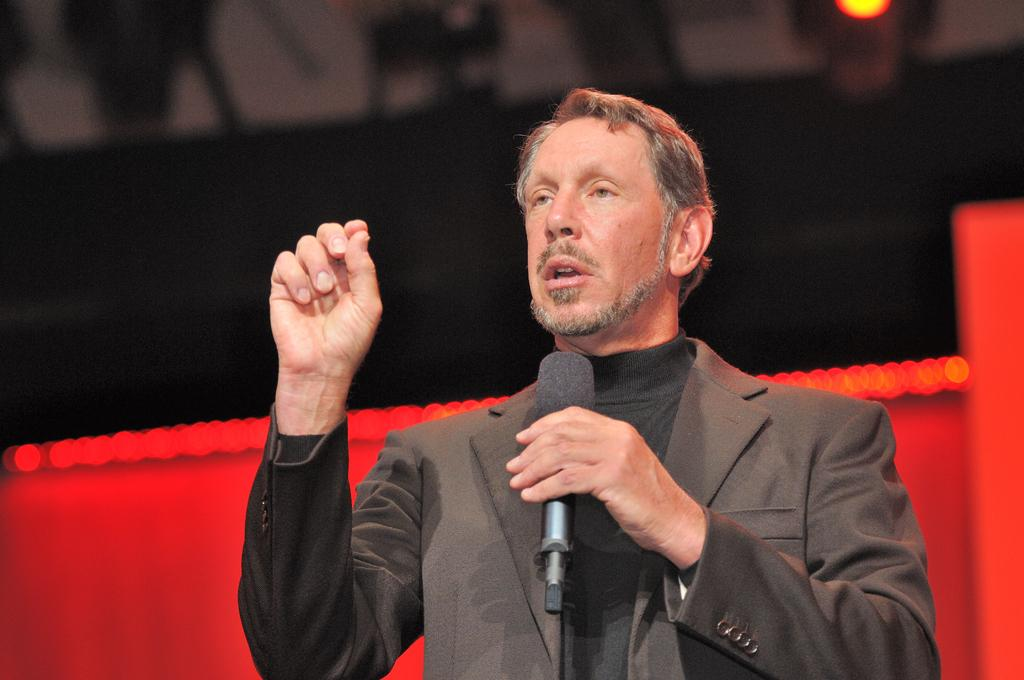Who is the main subject in the image? There is a man in the image. What is the man wearing? The man is wearing a black blazer. What is the man holding in his hands? The man is holding a microphone in his hands. Can you describe the background of the image? There is a black and red color background in the image. What type of jelly can be seen on the man's face in the image? There is no jelly present on the man's face in the image. How does the shade of the man's blazer change throughout the image? The man's blazer is consistently black throughout the image; there is no change in shade. 